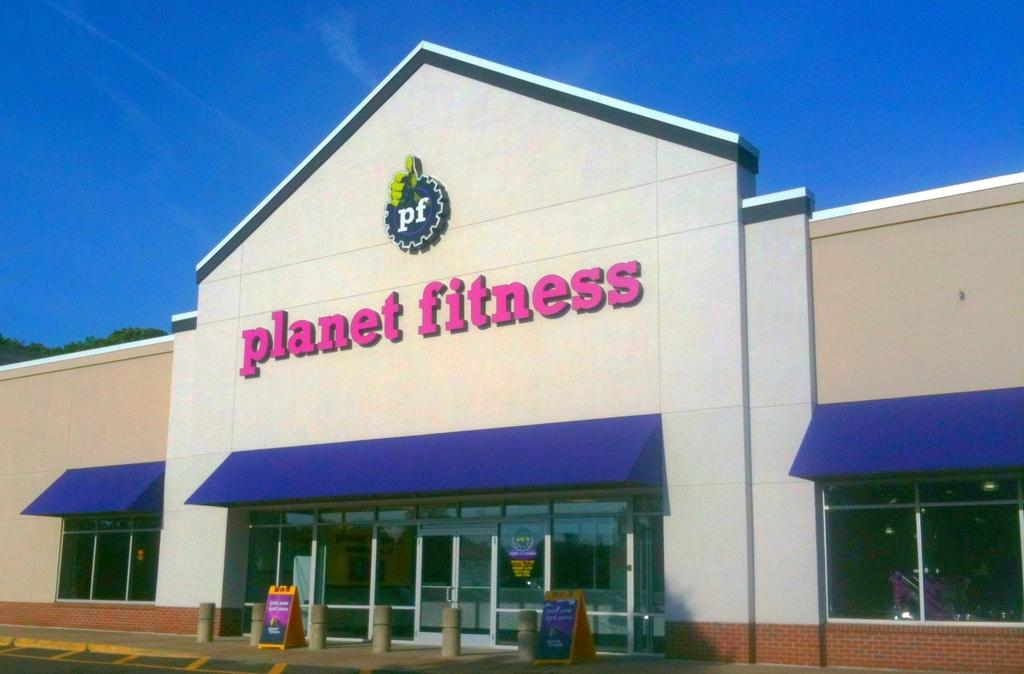What type of structure is present in the image? There is a building in the image. What features can be observed on the building? The building has windows and sun shades. Are there any decorations or signs on the building? Yes, there are banners on the building. What else can be seen in the image besides the building? There is a road and trees in the image. What is visible in the background of the image? The sky is visible in the background of the image. What type of surprise can be seen in the underwear of the person in the image? There is no person or underwear present in the image, so it is not possible to determine if there is a surprise or not. 